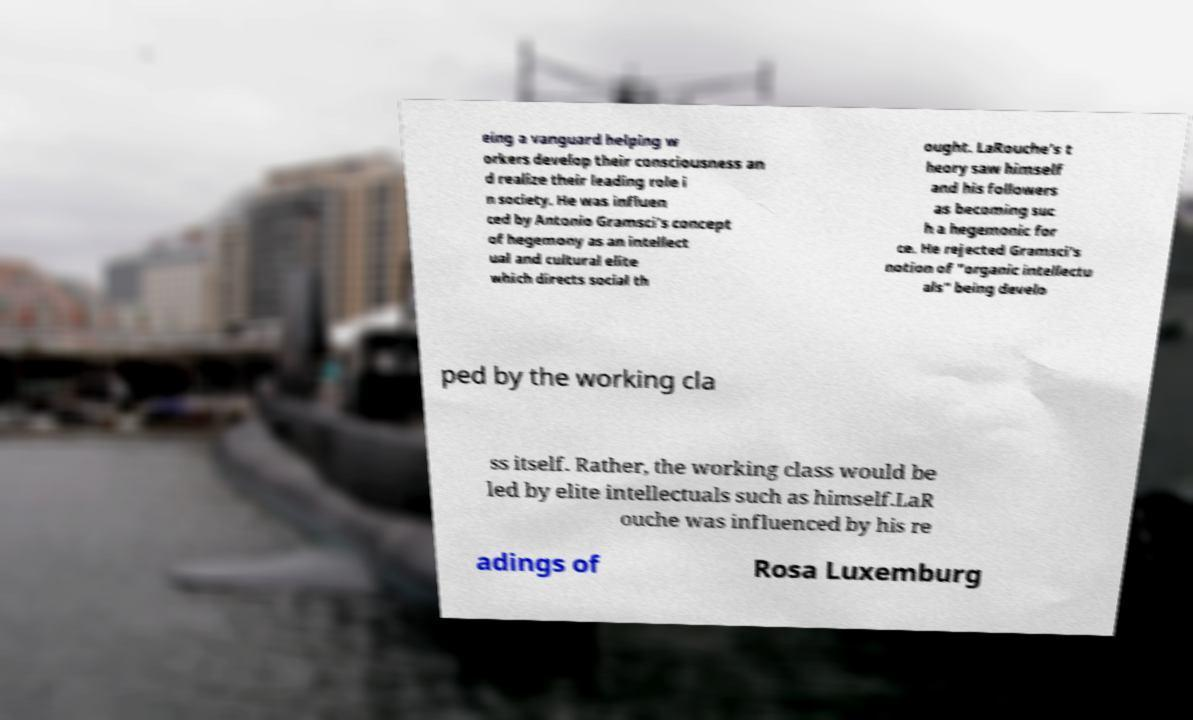There's text embedded in this image that I need extracted. Can you transcribe it verbatim? eing a vanguard helping w orkers develop their consciousness an d realize their leading role i n society. He was influen ced by Antonio Gramsci's concept of hegemony as an intellect ual and cultural elite which directs social th ought. LaRouche's t heory saw himself and his followers as becoming suc h a hegemonic for ce. He rejected Gramsci's notion of "organic intellectu als" being develo ped by the working cla ss itself. Rather, the working class would be led by elite intellectuals such as himself.LaR ouche was influenced by his re adings of Rosa Luxemburg 